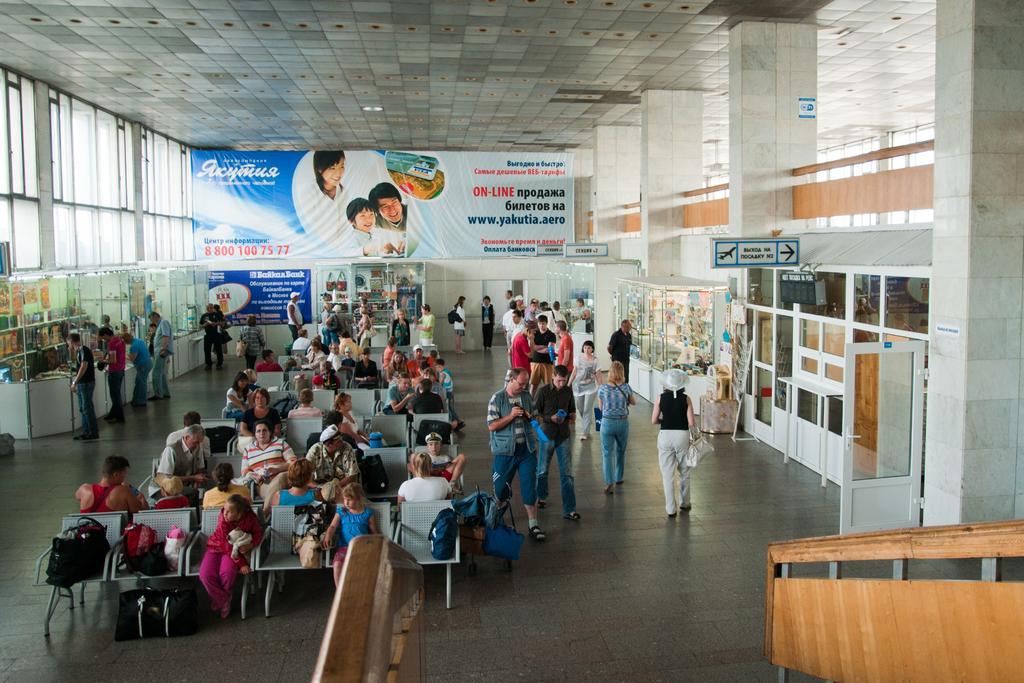Can you describe this image briefly? In this image we can see people, chairs, bags, banners and sign boards. Few people are walking and few people are sitting on chairs. These are glass windows. 